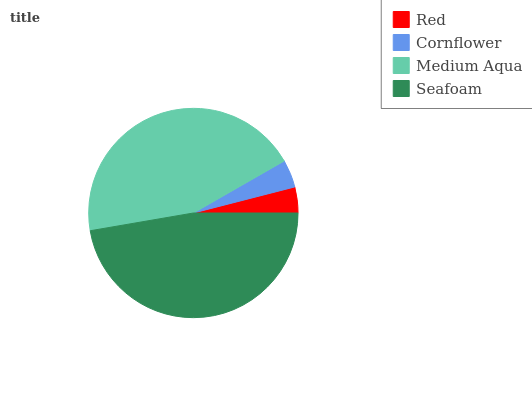Is Red the minimum?
Answer yes or no. Yes. Is Seafoam the maximum?
Answer yes or no. Yes. Is Cornflower the minimum?
Answer yes or no. No. Is Cornflower the maximum?
Answer yes or no. No. Is Cornflower greater than Red?
Answer yes or no. Yes. Is Red less than Cornflower?
Answer yes or no. Yes. Is Red greater than Cornflower?
Answer yes or no. No. Is Cornflower less than Red?
Answer yes or no. No. Is Medium Aqua the high median?
Answer yes or no. Yes. Is Cornflower the low median?
Answer yes or no. Yes. Is Cornflower the high median?
Answer yes or no. No. Is Red the low median?
Answer yes or no. No. 